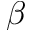Convert formula to latex. <formula><loc_0><loc_0><loc_500><loc_500>\beta</formula> 